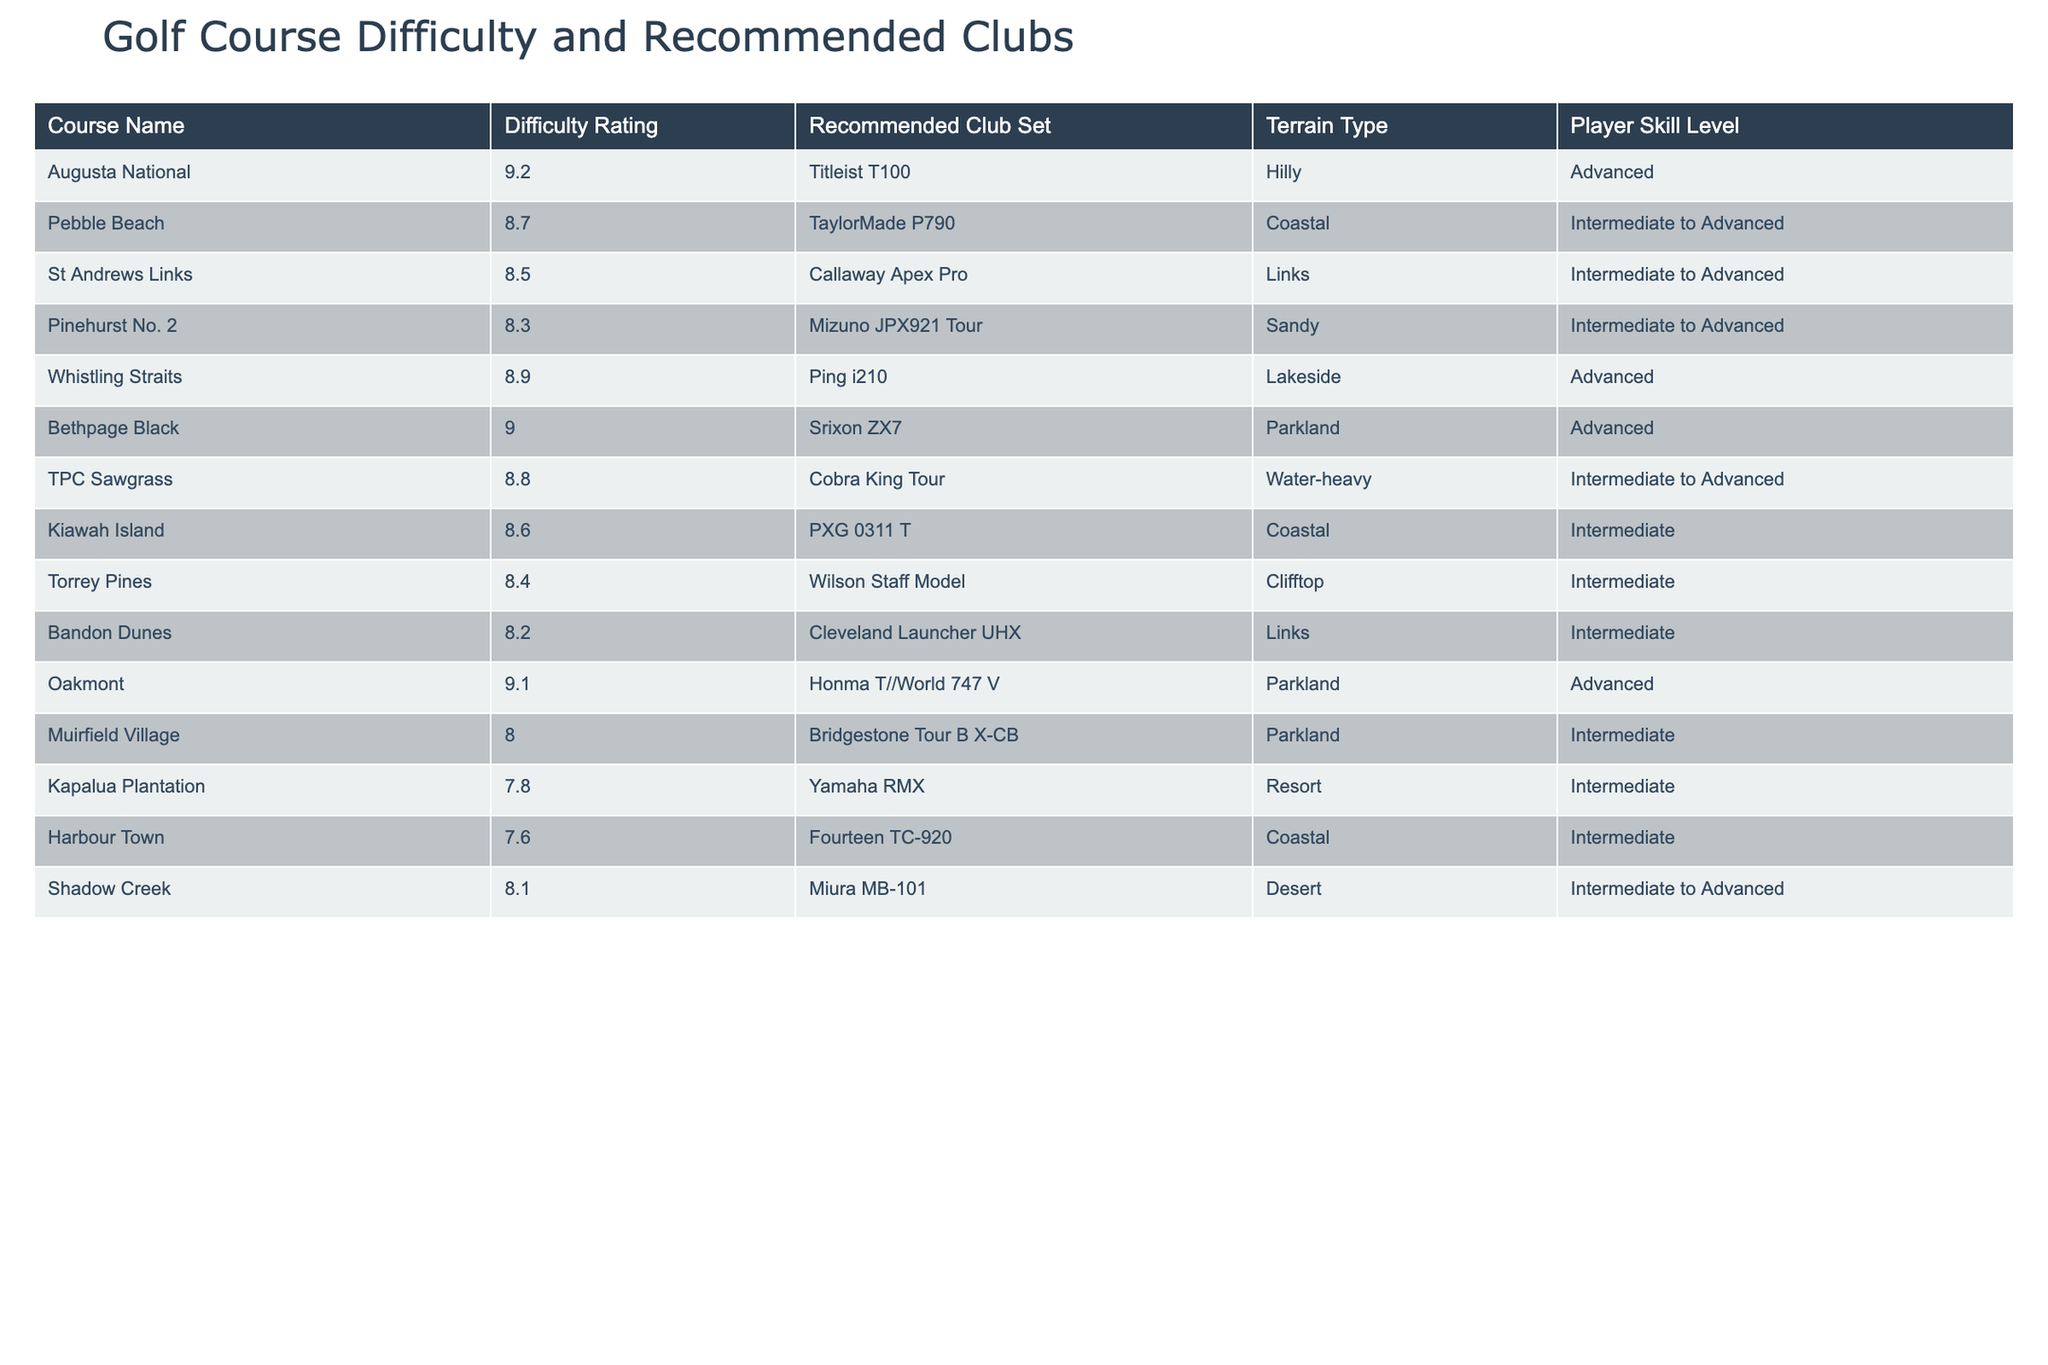What is the highest difficulty rating among the courses listed? The course with the highest difficulty rating can be found by scanning the "Difficulty Rating" column. The highest value is 9.2, which corresponds to Augusta National.
Answer: 9.2 Which recommended club set is associated with Pebble Beach? By locating Pebble Beach in the table and checking the "Recommended Club Set" column, we find that it recommends the TaylorMade P790.
Answer: TaylorMade P790 How many courses have a difficulty rating of 8.5 or higher? We can count the number of courses in the "Difficulty Rating" column that are 8.5 or above. The courses that meet this criterion are Augusta National, Pebble Beach, St Andrews Links, Bethpage Black, Oakmont, and Whistling Straits, totaling 6 courses.
Answer: 6 What terrain type is associated with the recommended club set Mizuno JPX921 Tour? The Mizuno JPX921 Tour is recommended for Pinehurst No. 2. Checking the table, Pinehurst No. 2 is on Sandy terrain.
Answer: Sandy Is there a course that has both a difficulty rating of 8.0 or higher and is on Desert terrain? By examining the table, we see that all courses with a rating of 8.0 or higher are either Hilly, Coastal, Links, Sandy, Lakeside, Parkland, or Clifftop, and there are no courses listed under Desert terrain that meet this rating. Therefore, the answer is no.
Answer: No What is the average difficulty rating of all the courses listed? To find the average, we sum all the difficulty ratings: (9.2 + 8.7 + 8.5 + 8.3 + 8.9 + 9.0 + 8.8 + 8.6 + 8.4 + 8.2 + 9.1 + 8.0 + 7.8 + 7.6 + 8.1) = 133.7. There are 15 courses, so we divide the total by 15: 133.7 / 15 ≈ 8.913.
Answer: 8.9 Which player skill level is associated with the course that has the lowest difficulty rating? The course with the lowest difficulty rating is Kapalua Plantation with a rating of 7.8. Referring to the table, it is associated with the "Intermediate" skill level.
Answer: Intermediate Can you identify a course with a recommended club set that is suitable for advanced players and also has a coastal terrain type? Looking through the list, while Pebble Beach has a coastal terrain, it is listed for Intermediate to Advanced players. The other coastal course, Kiawah Island, is suitable for Intermediate. No course meets the criteria of being both for advanced players and coastal.
Answer: No What club set would you recommend for someone playing at Whistling Straits? The recommended club set for Whistling Straits is found in the "Recommended Club Set" column, which indicates the Ping i210.
Answer: Ping i210 How many total courses are recommended for advanced players? By reviewing the "Player Skill Level" column, Augusta National, Whistling Straits, Bethpage Black, and Oakmont are the only courses listed for advanced players. This totals to 4 courses.
Answer: 4 Is the Callaway Apex Pro recommended for intermediate players? The Callaway Apex Pro is linked to St Andrews Links, which has a skill level of Intermediate to Advanced. Therefore, it can be utilized by Intermediate players as well.
Answer: Yes 